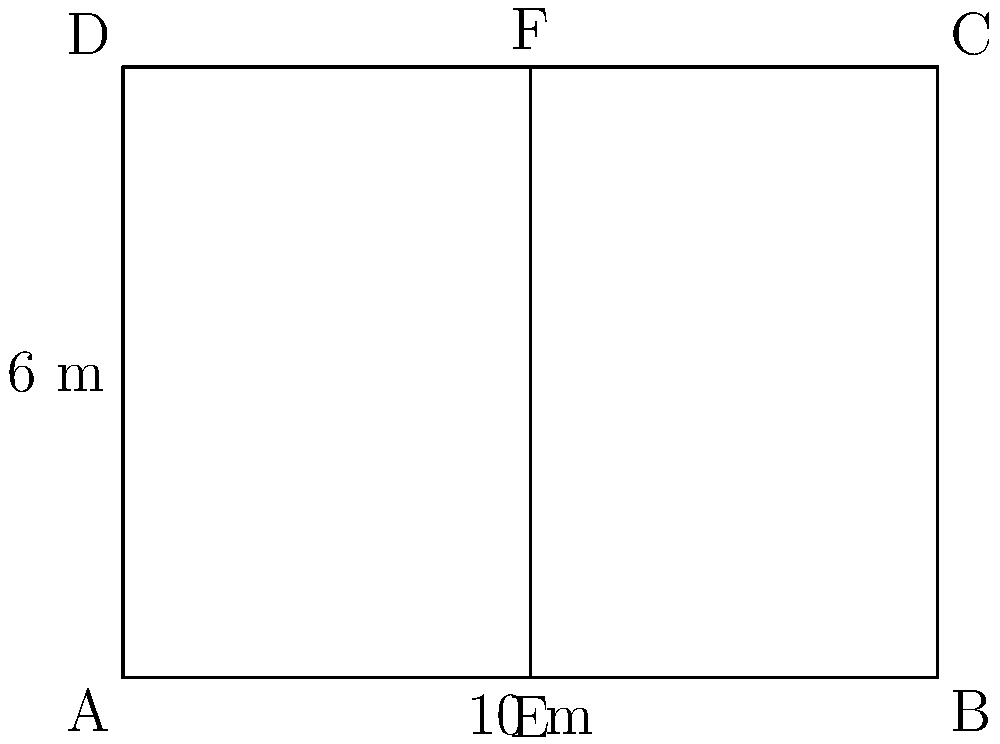While assisting the millionaire in designing the layout for a new luxury car garage, you come across a blueprint with the following dimensions. The garage is rectangular, measuring 10 meters in length and 6 meters in width. A support beam runs vertically through the center of the garage. If segment AE is congruent to segment EB, what is the length of segment EF in meters? Let's approach this step-by-step:

1) First, we need to understand what the question is asking. We're looking for the length of EF, which is the vertical support beam in the center of the garage.

2) We're told that AE is congruent to EB. This means that point E is exactly in the middle of AB.

3) We know the total length of the garage (AB) is 10 meters. So:
   $AE = EB = \frac{1}{2} AB = \frac{1}{2} \times 10 = 5$ meters

4) Now, we need to find the height of the garage, which is the same as the length of EF.

5) The width of the garage (AD or BC) is given as 6 meters.

6) Since EF is a vertical line from the midpoint of AB to the midpoint of DC, it must be equal in length to AD or BC.

7) Therefore, the length of EF is also 6 meters.
Answer: 6 meters 